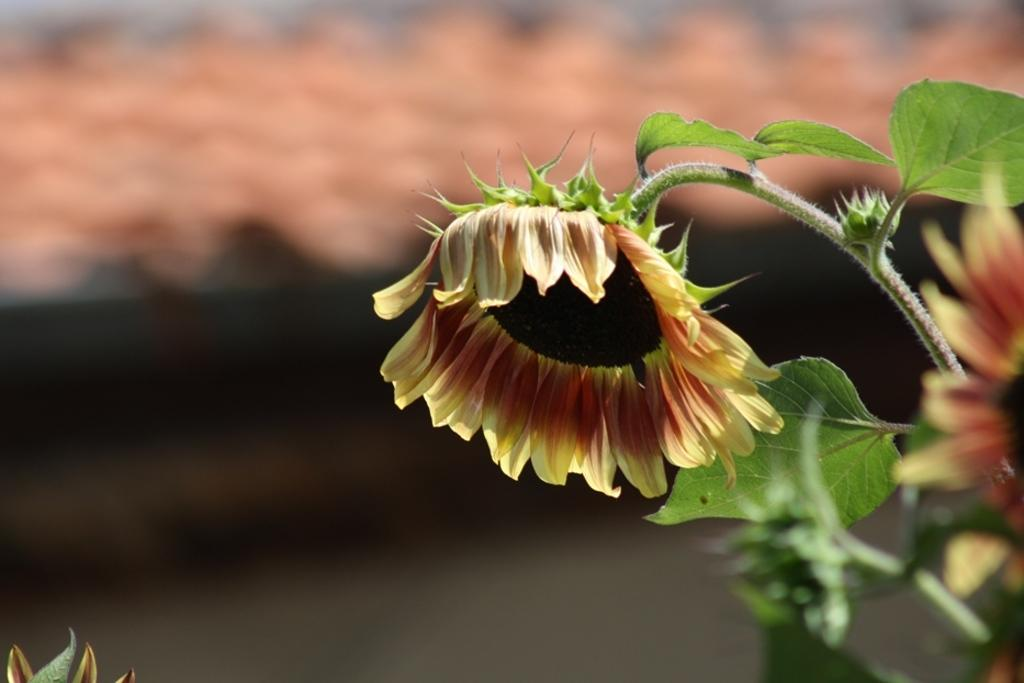What type of plants can be seen in the image? The image contains flowers. What colors are the flowers in the image? The flowers are yellow and red in color. Are there any other parts of the plants visible in the image? Yes, the image contains leaves. What type of coach is present in the image? There is no coach present in the image; it contains flowers and leaves. 